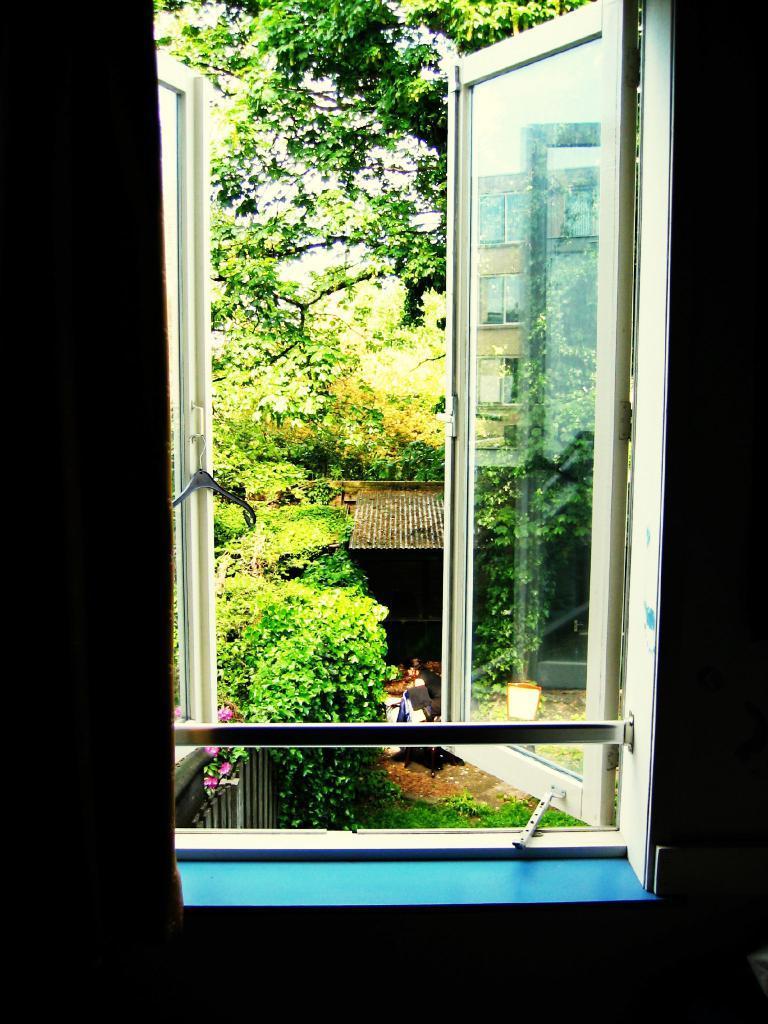In one or two sentences, can you explain what this image depicts? In this picture we can see a glass window here, we can see trees, a sheet, some flowers and grass here. 